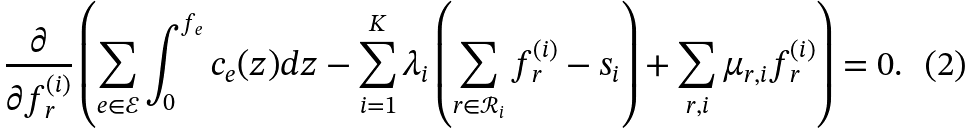Convert formula to latex. <formula><loc_0><loc_0><loc_500><loc_500>\frac { \partial } { \partial f _ { r } ^ { ( i ) } } \left ( \sum _ { e \in \mathcal { E } } \int _ { 0 } ^ { f _ { e } } c _ { e } ( z ) d z - \sum _ { i = 1 } ^ { K } \lambda _ { i } \left ( \sum _ { r \in \mathcal { R } _ { i } } f _ { r } ^ { ( i ) } - s _ { i } \right ) + \sum _ { r , i } \mu _ { r , i } f _ { r } ^ { ( i ) } \right ) = 0 .</formula> 